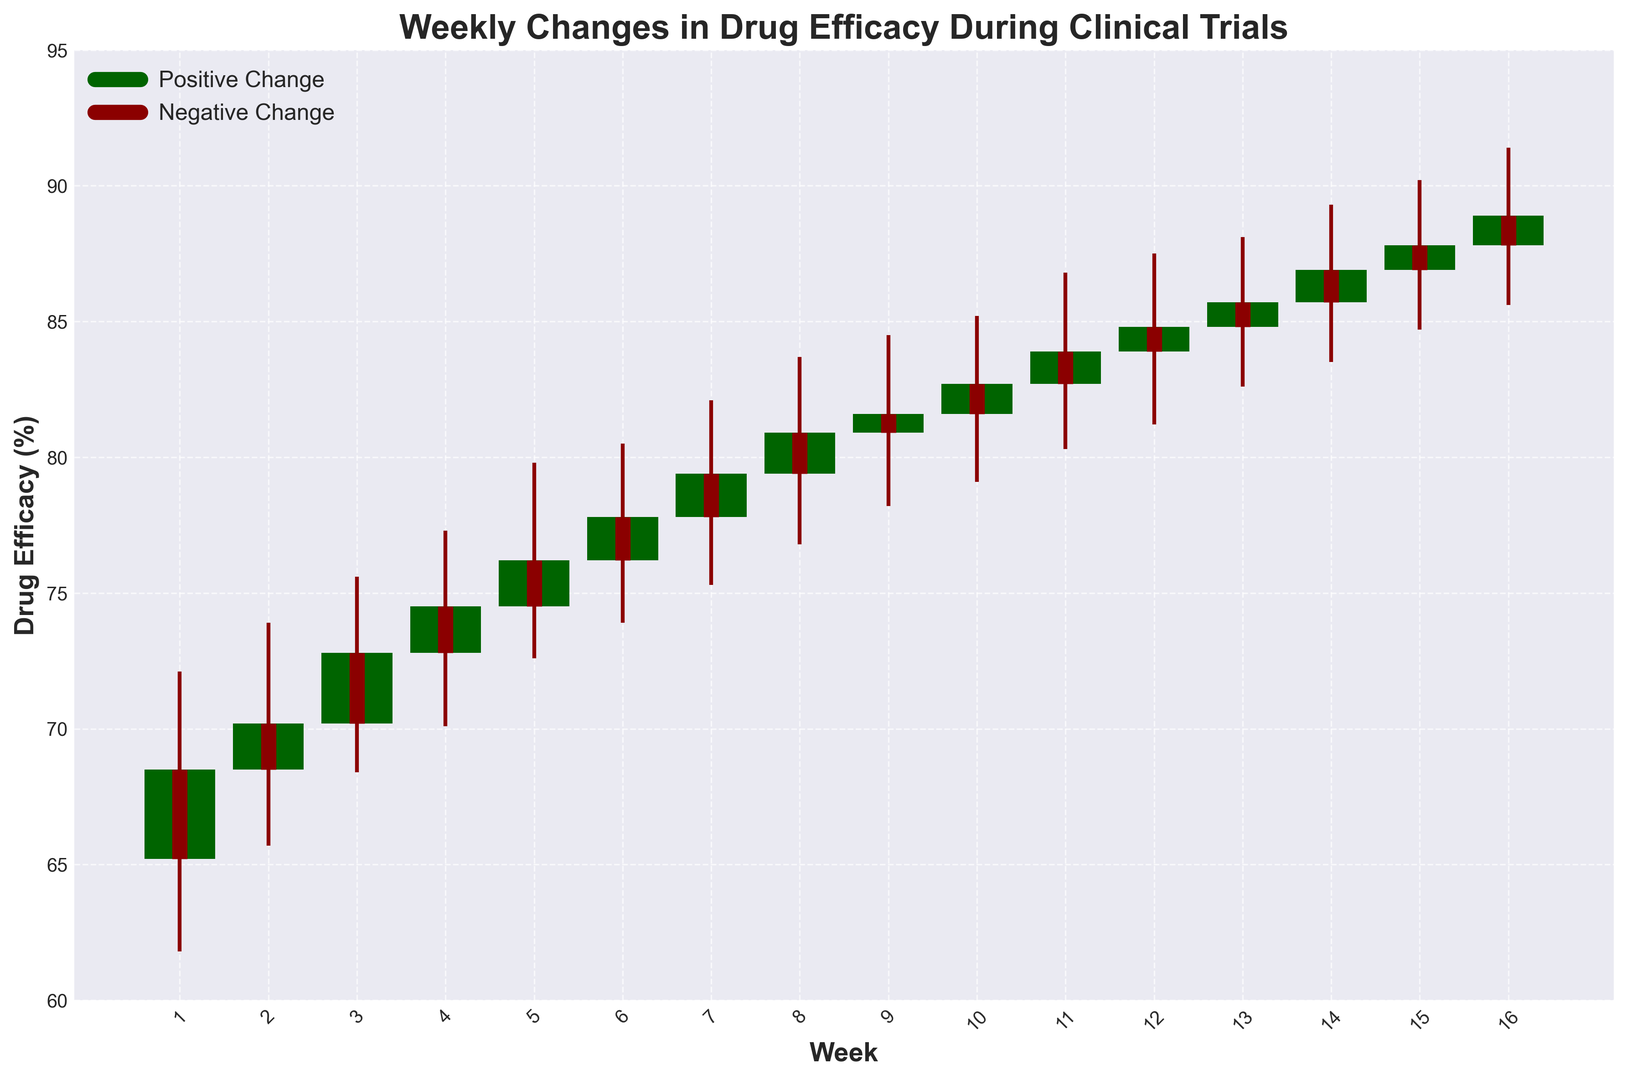What week shows the largest increase in drug efficacy? The increase in drug efficacy can be observed from the differences between the Close and Open values in each week. The largest positive difference indicates the largest increase. Week 14 shows a significant positive change with the Close value (86.9) being higher than the Open value (85.7) by 1.2%.
Answer: Week 14 In which week did the drug efficacy decrease the most comparably between the opening and closing rates? A decrease in drug efficacy is marked by a negative difference between the Close and Open values. The largest negative difference can be observed in a specific week. Week 1 has the largest decrease as the Close value (68.5) is lower than the Open value (65.2) by -3.3% difference.
Answer: Week 1 What is the drug efficacy range (difference between High and Low) for Week 10? The range of drug efficacy for any given week is calculated by subtracting the Low value from the High value. For Week 10, subtract the Low (79.1) from the High (85.2) to get the range: 85.2 - 79.1 = 6.1.
Answer: 6.1 Compare the efficacy on Week 5 with Week 15. Did the drug perform better or worse on one of these weeks? Comparing the Close values for Week 5 and Week 15 can tell us the performance. For Week 5, the Close value is 76.2. For Week 15, the Close value is 87.8. Since 87.8 is greater than 76.2, the drug performed better on Week 15.
Answer: Week 15 Which week had the maximum High value and what was it? The High value represents the maximum drug efficacy recorded in a week. Scanning the High values for each week, Week 16 has the highest maximum value (91.4).
Answer: Week 16, 91.4 What is the average opening efficacy rate for the first 4 weeks? To find the average, sum the Open values for the first 4 weeks and divide by 4: (65.2 + 68.5 + 70.2 + 72.8) / 4 = 276.7 / 4 = 69.18.
Answer: 69.18 How did the efficacy change in Week 8 from the open to the close? The change from open to close in Week 8 is calculated by subtracting the Open value from the Close value: 80.9 - 79.4 = 1.5. So there was a 1.5% increase in efficacy.
Answer: Increased by 1.5 Is there any week where the drug efficacy closed at exactly 80? Checking each week's Close value from the provided data between Weeks 1 and 16, none of the Close values exactly equals 80%.
Answer: No How many weeks had a negative change in efficacy from the opening to the closing rate? Counting the weeks where the Close value is less than the Open value, we find: Weeks 1 (68.5 < 65.2). So there is one week with a negative change.
Answer: 1 Week During which week did the drug achieve its highest closing efficacy rate and what was the value? The highest closing efficacy rate can be determined by looking at the Close values. The highest Close value is found in Week 16 with a Close value of 88.9.
Answer: Week 16, 88.9 